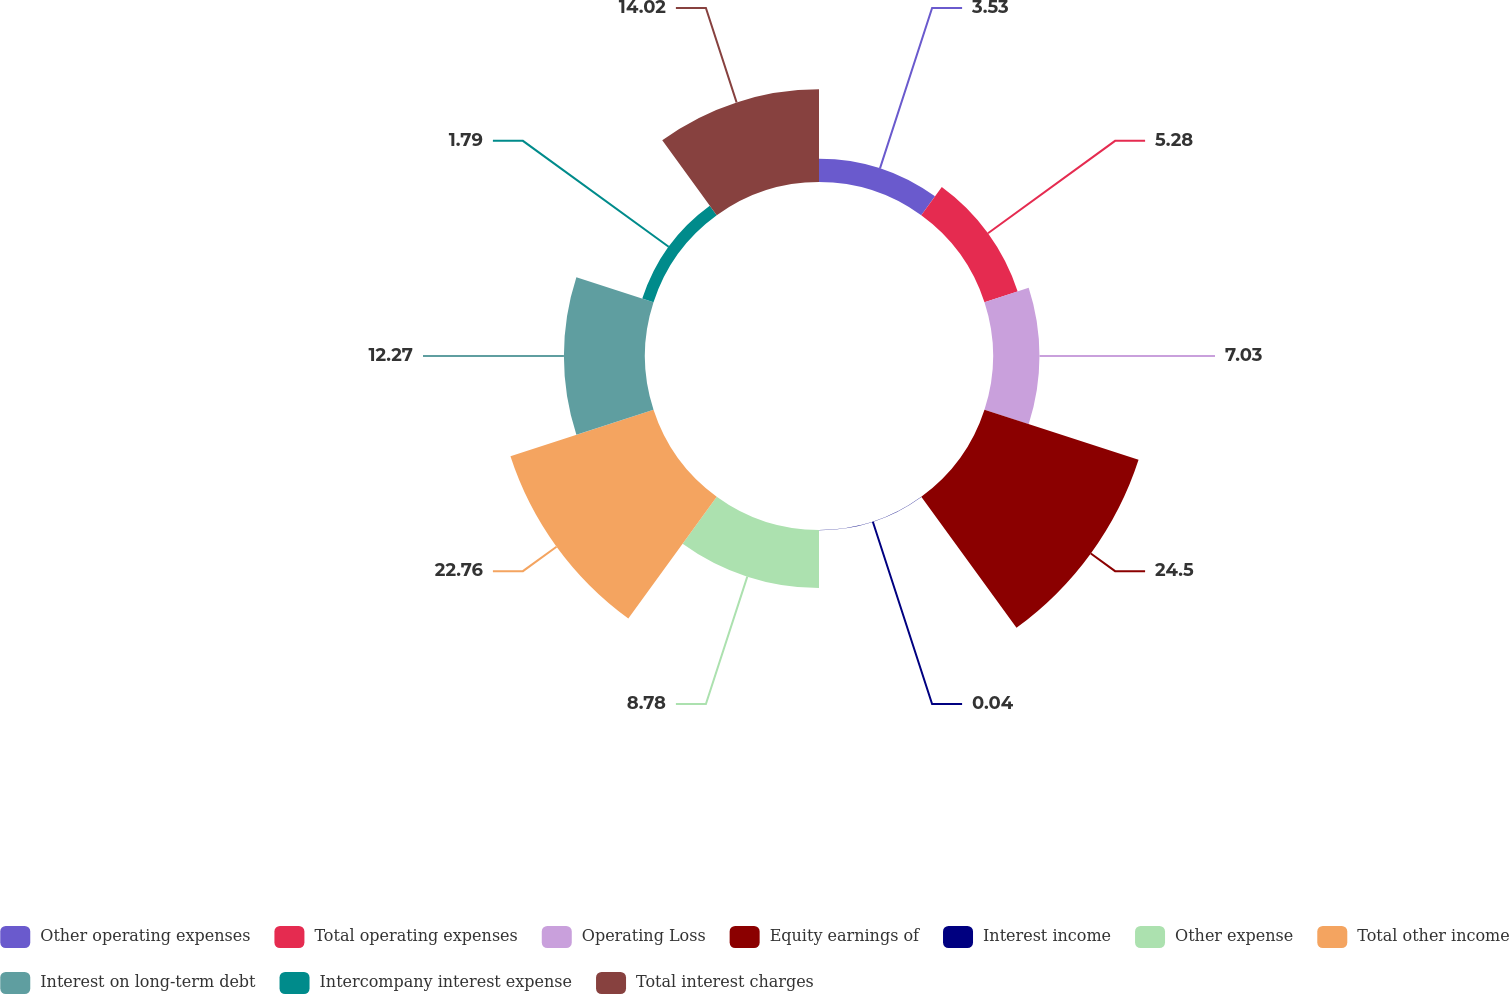Convert chart to OTSL. <chart><loc_0><loc_0><loc_500><loc_500><pie_chart><fcel>Other operating expenses<fcel>Total operating expenses<fcel>Operating Loss<fcel>Equity earnings of<fcel>Interest income<fcel>Other expense<fcel>Total other income<fcel>Interest on long-term debt<fcel>Intercompany interest expense<fcel>Total interest charges<nl><fcel>3.53%<fcel>5.28%<fcel>7.03%<fcel>24.51%<fcel>0.04%<fcel>8.78%<fcel>22.76%<fcel>12.27%<fcel>1.79%<fcel>14.02%<nl></chart> 